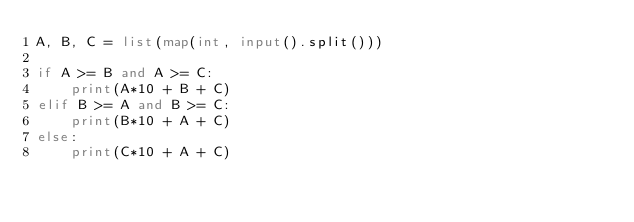Convert code to text. <code><loc_0><loc_0><loc_500><loc_500><_Python_>A, B, C = list(map(int, input().split()))

if A >= B and A >= C:
    print(A*10 + B + C)
elif B >= A and B >= C:
    print(B*10 + A + C)
else:
    print(C*10 + A + C)</code> 